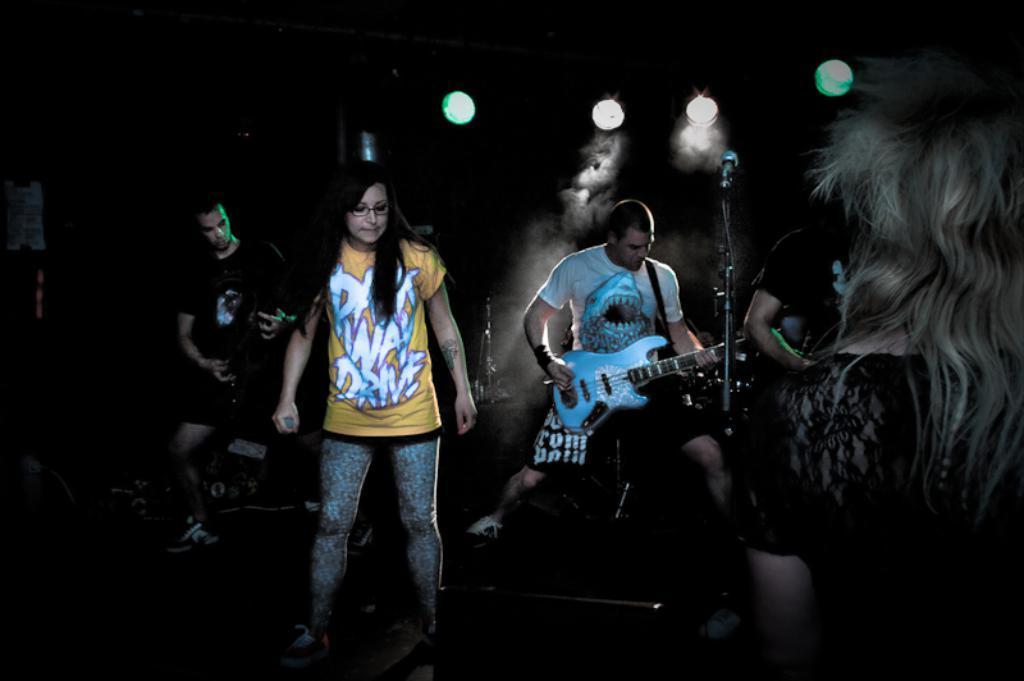Describe this image in one or two sentences. This picture they are three people, two are playing the guitar and one of them is holding a microphone in her right hand,there are also disco lights attached to the ceiling. 